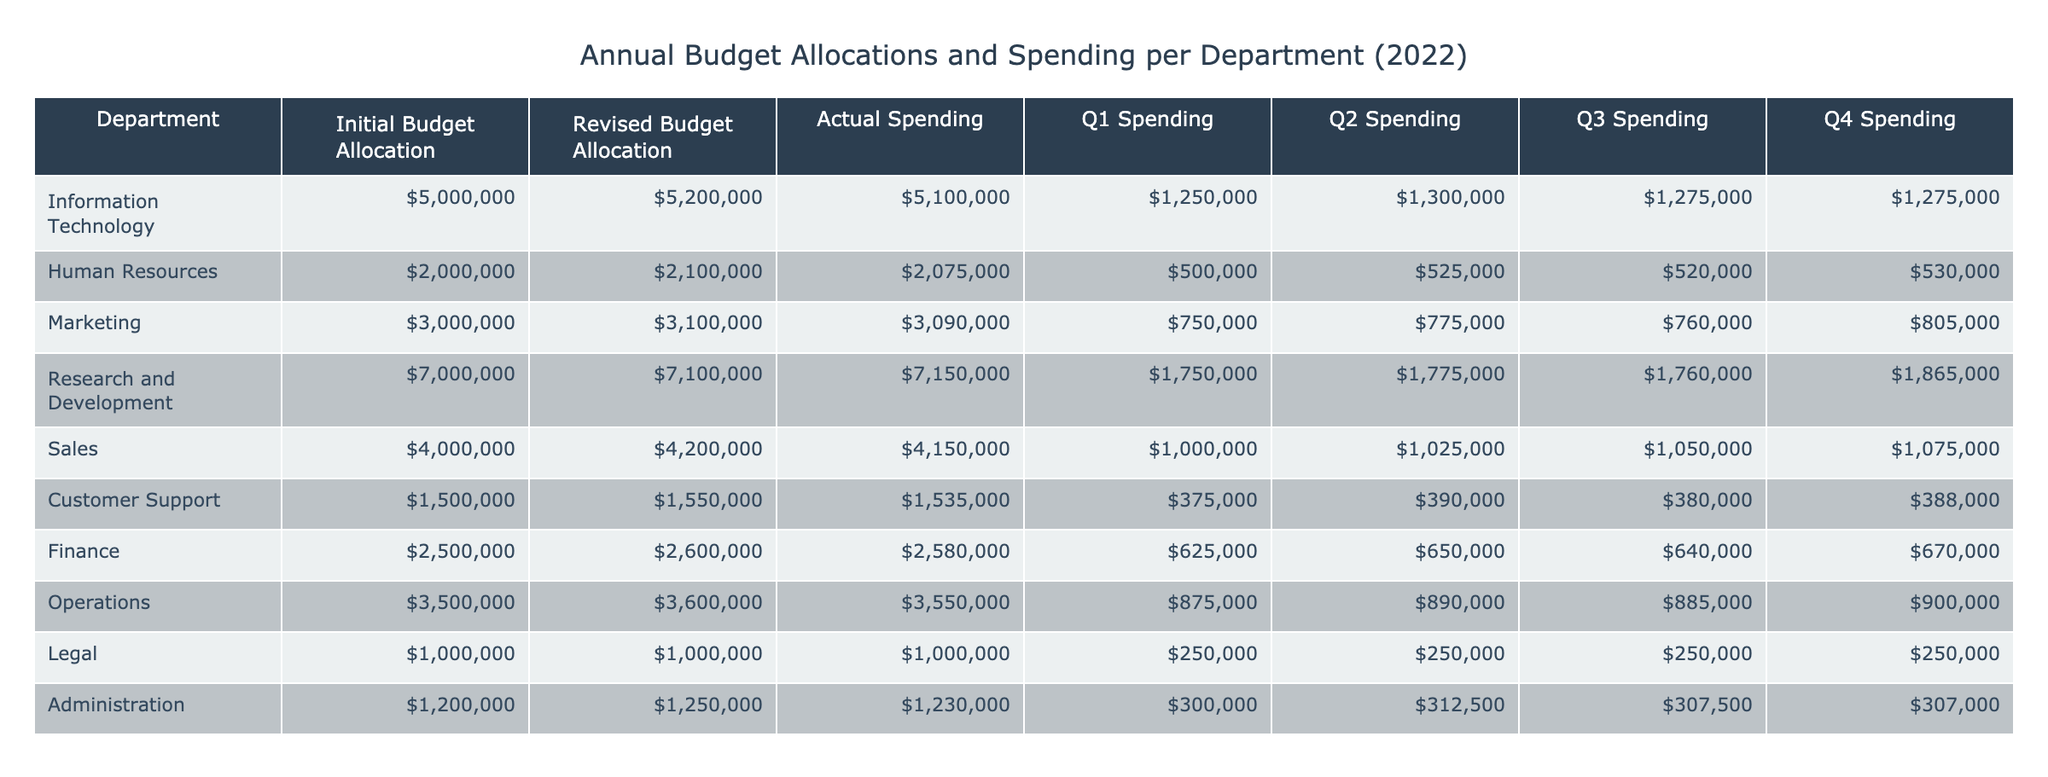What was the initial budget allocation for the Marketing department? Looking at the "Initial Budget Allocation" column for the Marketing department, it shows an allocation of 3000000.
Answer: 3000000 What is the total actual spending for all departments combined? To find the total actual spending, sum all the values in the "Actual Spending" column: 5100000 + 2075000 + 3090000 + 7150000 + 4150000 + 1535000 + 2580000 + 3550000 + 1000000 + 1230000 =  18545000.
Answer: 18545000 Did the Finance department spend more than they allocated in their revised budget? The revised budget allocation for Finance is 2600000 and the actual spending is 2580000, which is less than the revised budget.
Answer: No Which department had the highest spending in Q4? Looking at the "Q4 Spending" column, the highest value is 1275000 for the Information Technology department.
Answer: Information Technology What is the average spending per quarter for the Research and Development department? First, we sum the spending for each quarter, which is Q1 (1750000) + Q2 (1775000) + Q3 (1760000) + Q4 (1865000) = 7150000. We then divide by the number of quarters, which is 4, resulting in an average of 7150000 / 4 = 1787500.
Answer: 1787500 Did the Customer Support department spend the same amount in all quarters? Checking the "Q1 Spending", "Q2 Spending", "Q3 Spending", and "Q4 Spending" for Customer Support, the amounts are 375000, 390000, 380000, and 388000, which are not equal.
Answer: No What percentage of the initial budget allocation did the Operations department actually spend? The initial budget allocation for Operations is 3600000 and the actual spending is 3550000. To find the percentage spent, we calculate (3550000 / 3600000) * 100 which equals approximately 98.61%.
Answer: 98.61% Which department had the smallest difference between the revised budget allocation and actual spending? We calculate the difference for each department: Information Technology (5200000 - 5100000 = 100000), Human Resources (2100000 - 2075000 = 25000), etc. The smallest difference is for Human Resources at 25000.
Answer: Human Resources How much more did the Sales department spend in Q2 compared to Q1? The Q2 spending for Sales is 1025000 and Q1 is 1000000. The difference is 1025000 - 1000000 = 25000.
Answer: 25000 